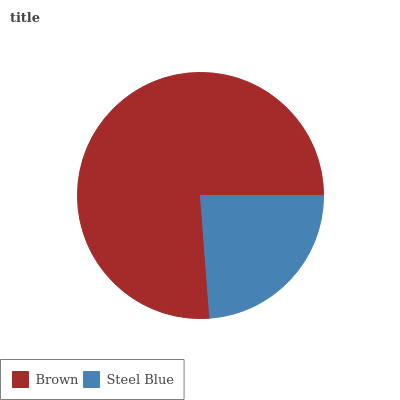Is Steel Blue the minimum?
Answer yes or no. Yes. Is Brown the maximum?
Answer yes or no. Yes. Is Steel Blue the maximum?
Answer yes or no. No. Is Brown greater than Steel Blue?
Answer yes or no. Yes. Is Steel Blue less than Brown?
Answer yes or no. Yes. Is Steel Blue greater than Brown?
Answer yes or no. No. Is Brown less than Steel Blue?
Answer yes or no. No. Is Brown the high median?
Answer yes or no. Yes. Is Steel Blue the low median?
Answer yes or no. Yes. Is Steel Blue the high median?
Answer yes or no. No. Is Brown the low median?
Answer yes or no. No. 